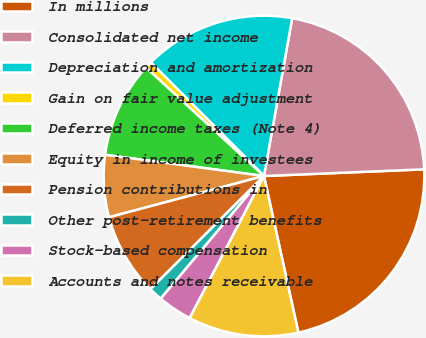<chart> <loc_0><loc_0><loc_500><loc_500><pie_chart><fcel>In millions<fcel>Consolidated net income<fcel>Depreciation and amortization<fcel>Gain on fair value adjustment<fcel>Deferred income taxes (Note 4)<fcel>Equity in income of investees<fcel>Pension contributions in<fcel>Other post-retirement benefits<fcel>Stock-based compensation<fcel>Accounts and notes receivable<nl><fcel>22.22%<fcel>21.52%<fcel>15.28%<fcel>0.7%<fcel>9.72%<fcel>6.25%<fcel>8.33%<fcel>1.39%<fcel>3.47%<fcel>11.11%<nl></chart> 